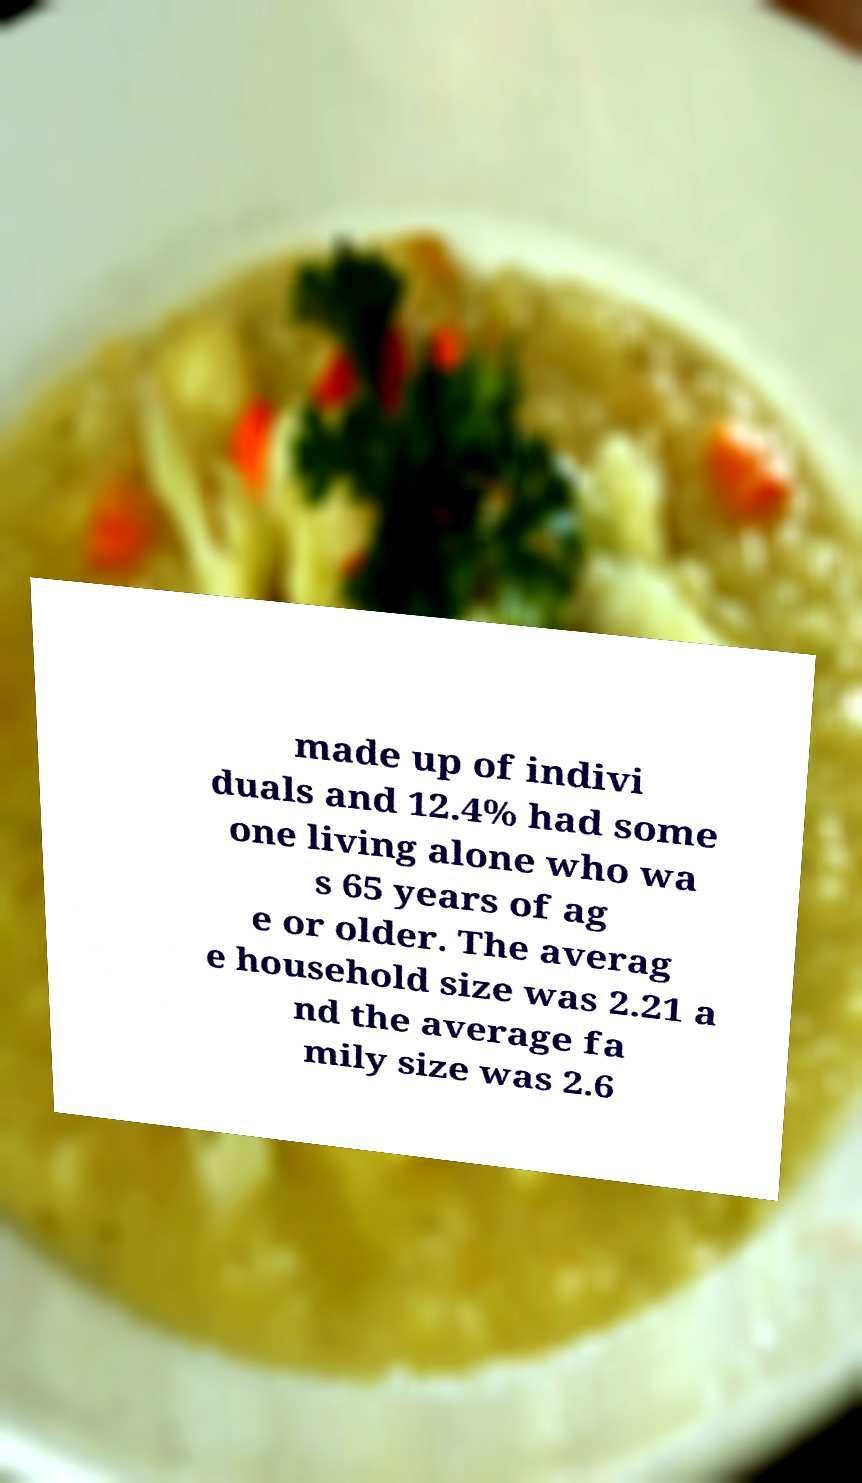Please identify and transcribe the text found in this image. made up of indivi duals and 12.4% had some one living alone who wa s 65 years of ag e or older. The averag e household size was 2.21 a nd the average fa mily size was 2.6 